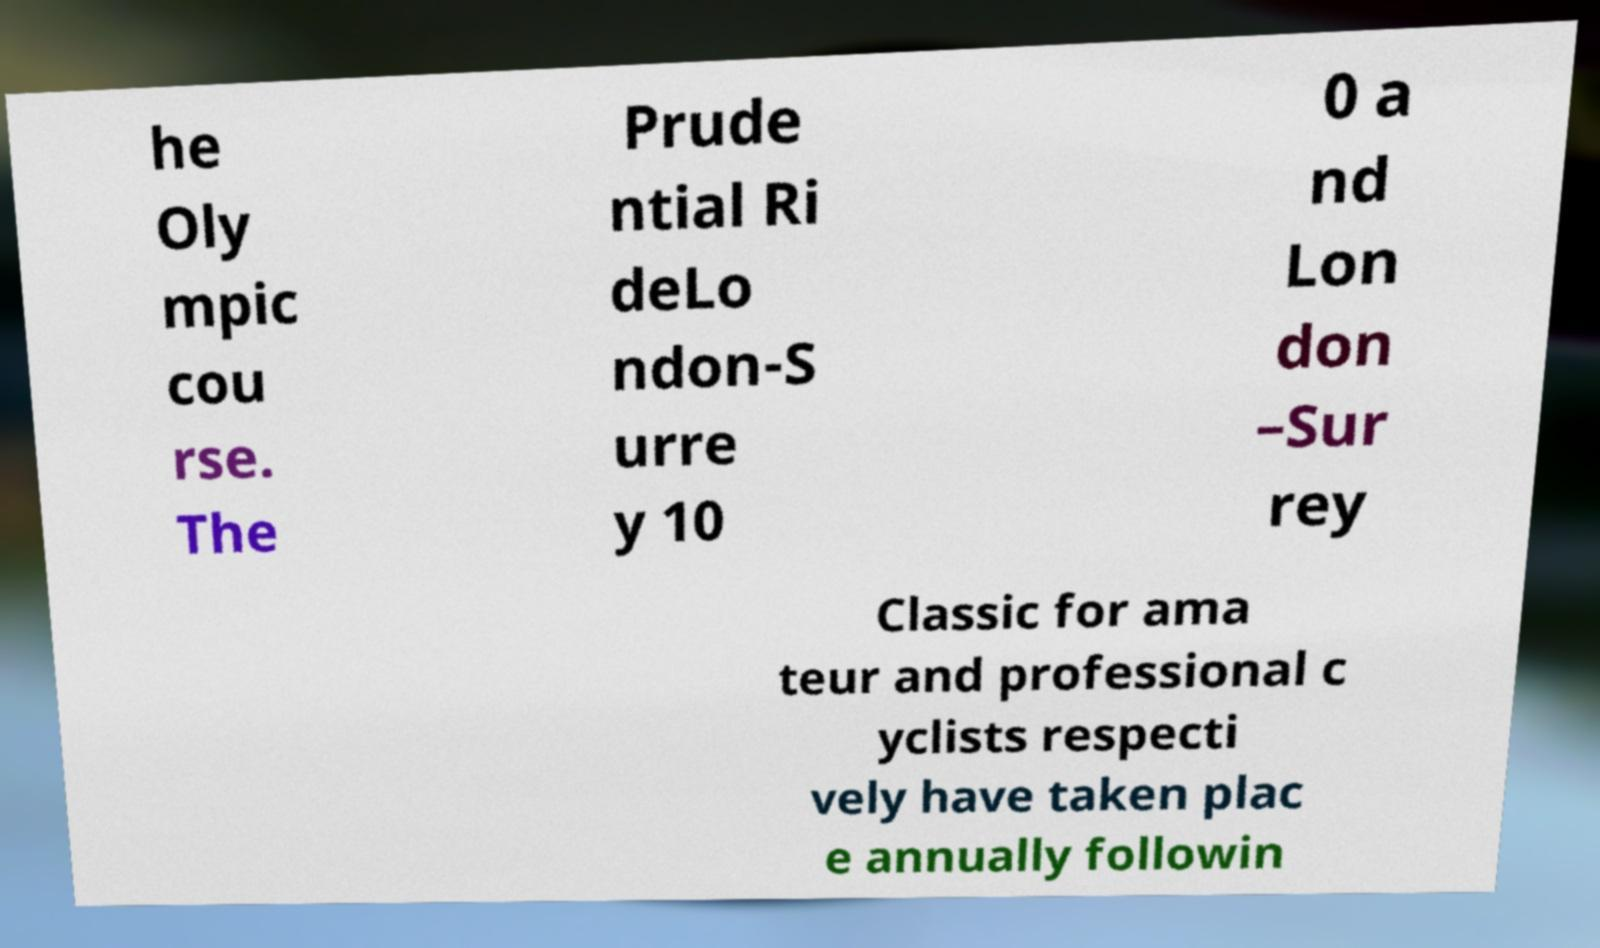Please identify and transcribe the text found in this image. he Oly mpic cou rse. The Prude ntial Ri deLo ndon-S urre y 10 0 a nd Lon don –Sur rey Classic for ama teur and professional c yclists respecti vely have taken plac e annually followin 